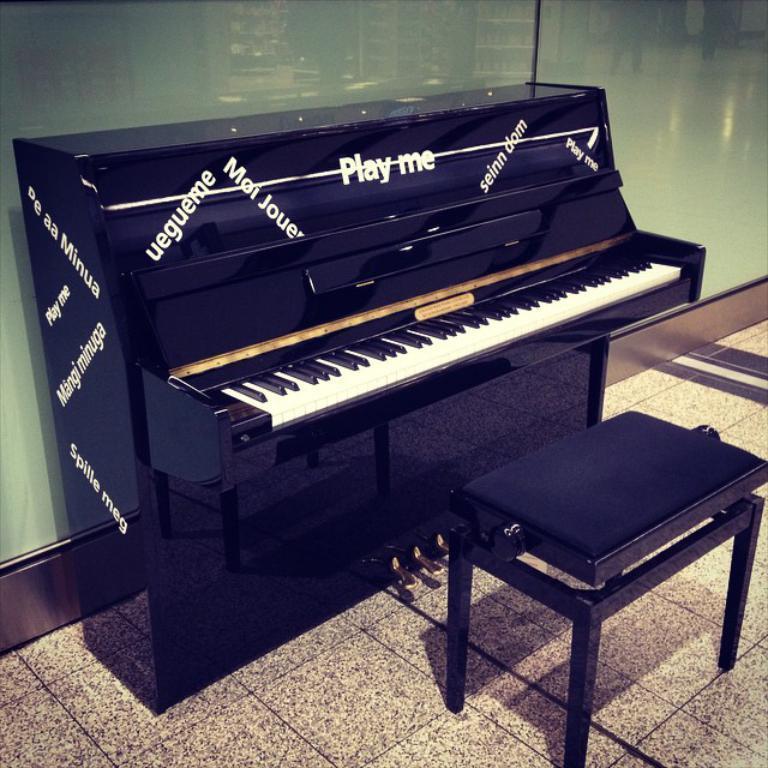In one or two sentences, can you explain what this image depicts? In this picture there is a piano, there is a chair in front of it. In the background there is a glass. 